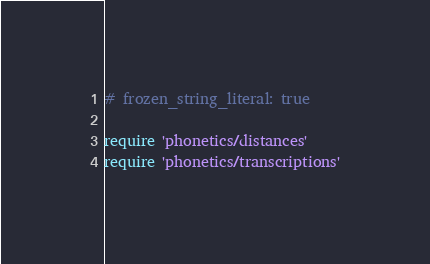<code> <loc_0><loc_0><loc_500><loc_500><_Ruby_># frozen_string_literal: true

require 'phonetics/distances'
require 'phonetics/transcriptions'
</code> 